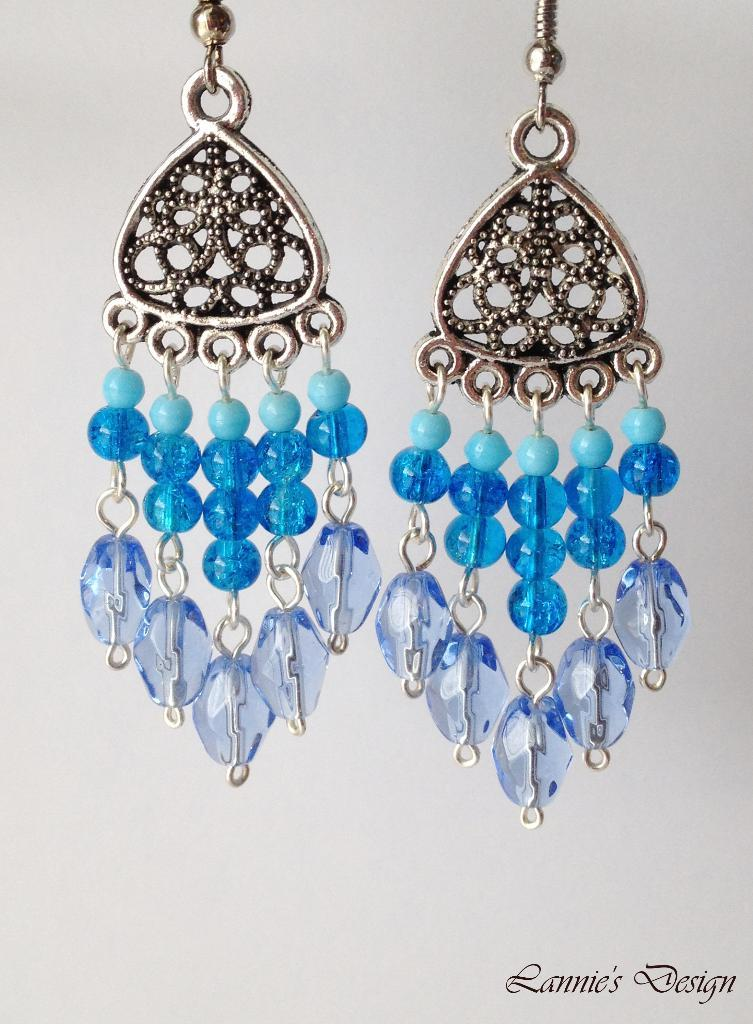What is the color of the background in the image? The background of the image is gray in color. What is the main subject of the image? There is a pair of earrings in the middle of the image. What type of seed can be seen growing in the image? There is no seed present in the image; it features a pair of earrings and a gray background. What kind of cub is visible in the image? There is no cub present in the image; it only features a pair of earrings and a gray background. 